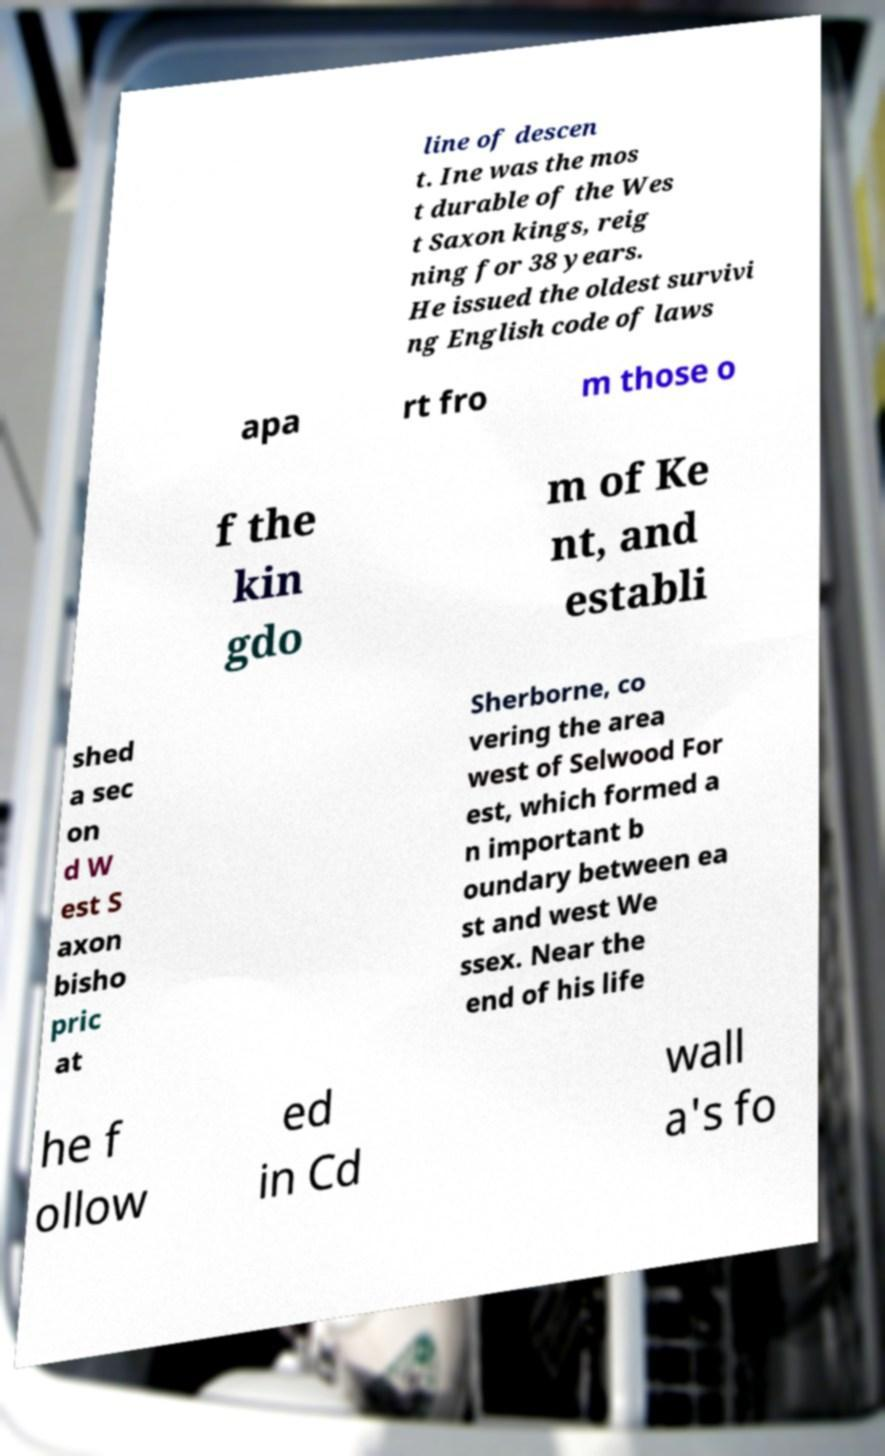There's text embedded in this image that I need extracted. Can you transcribe it verbatim? line of descen t. Ine was the mos t durable of the Wes t Saxon kings, reig ning for 38 years. He issued the oldest survivi ng English code of laws apa rt fro m those o f the kin gdo m of Ke nt, and establi shed a sec on d W est S axon bisho pric at Sherborne, co vering the area west of Selwood For est, which formed a n important b oundary between ea st and west We ssex. Near the end of his life he f ollow ed in Cd wall a's fo 